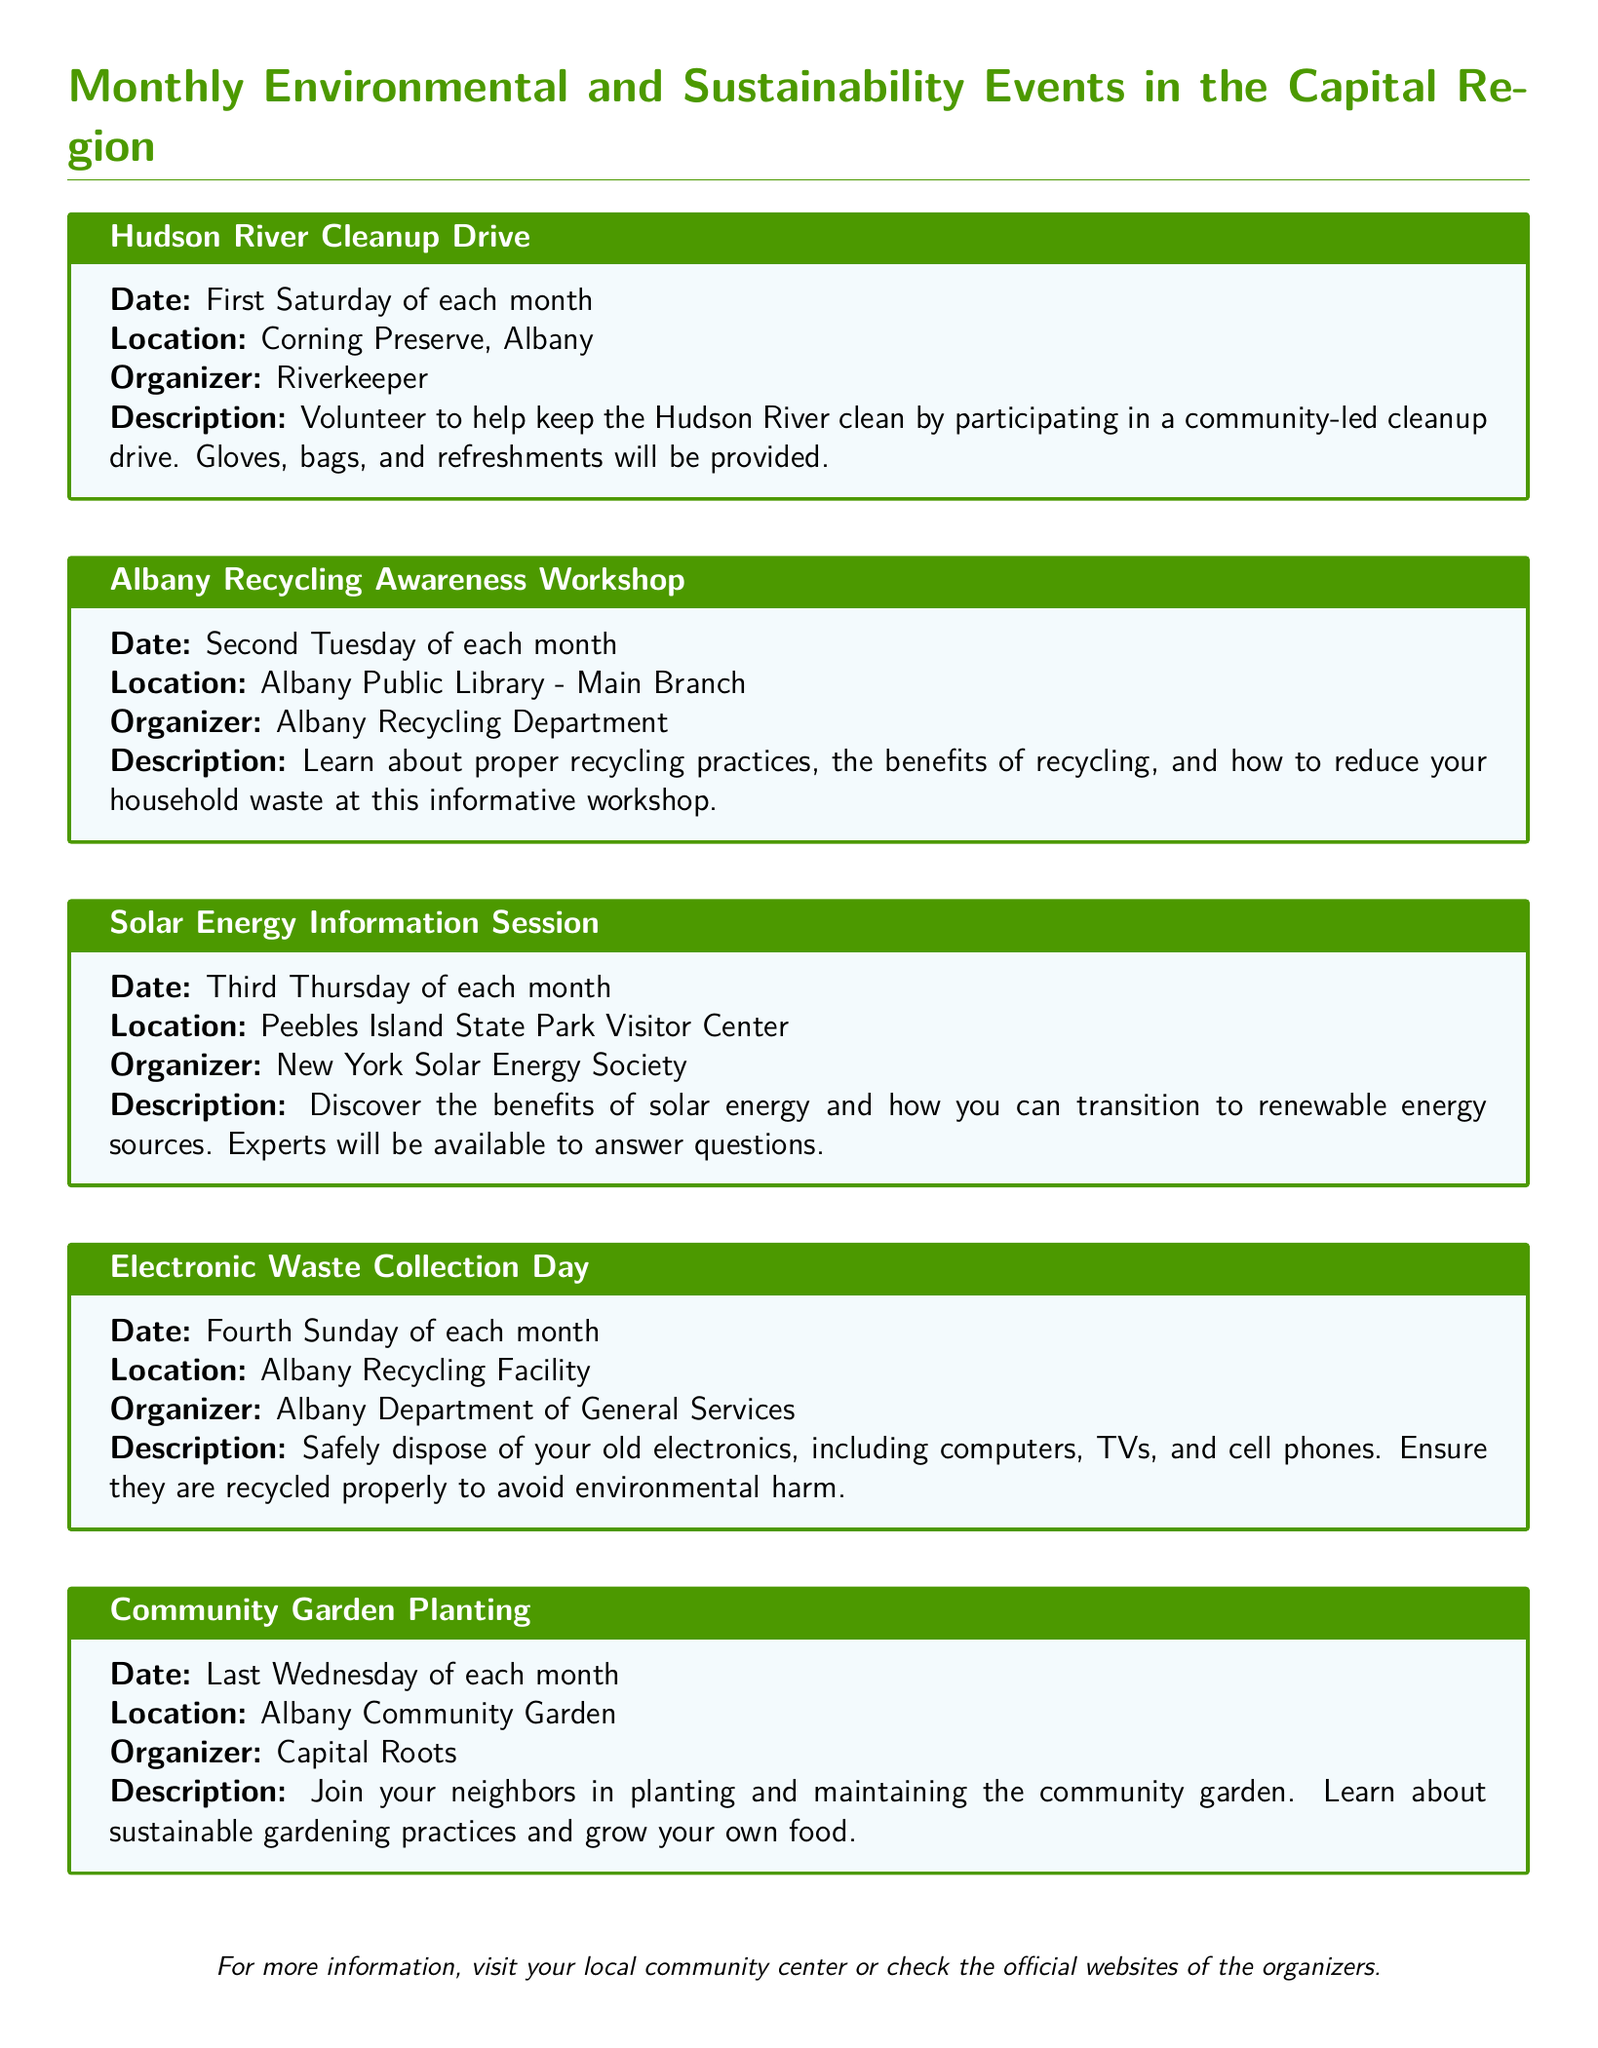What is the title of the first event? The title of the first event listed in the document is "Hudson River Cleanup Drive."
Answer: Hudson River Cleanup Drive When is the Albany Recycling Awareness Workshop held? The Albany Recycling Awareness Workshop takes place on the second Tuesday of each month.
Answer: Second Tuesday of each month Where will the Solar Energy Information Session be held? The location for the Solar Energy Information Session is Peebles Island State Park Visitor Center.
Answer: Peebles Island State Park Visitor Center Who organizes the Electronic Waste Collection Day? The organizer of the Electronic Waste Collection Day is the Albany Department of General Services.
Answer: Albany Department of General Services How often does the Community Garden Planting occur? The Community Garden Planting occurs once a month, specifically on the last Wednesday.
Answer: Last Wednesday of each month What item types can be disposed of during the Electronic Waste Collection Day? The document indicates that old electronics, including computers, TVs, and cell phones, can be disposed of.
Answer: Computers, TVs, and cell phones What is provided during the Hudson River Cleanup Drive? The document states that gloves, bags, and refreshments will be provided during the cleanup drive.
Answer: Gloves, bags, and refreshments What can participants learn at the Albany Recycling Awareness Workshop? Participants can learn about proper recycling practices and benefits at the Albany Recycling Awareness Workshop.
Answer: Proper recycling practices Is the Solar Energy Information Session focused on a specific type of energy? Yes, the Solar Energy Information Session specifically focuses on solar energy.
Answer: Solar energy 